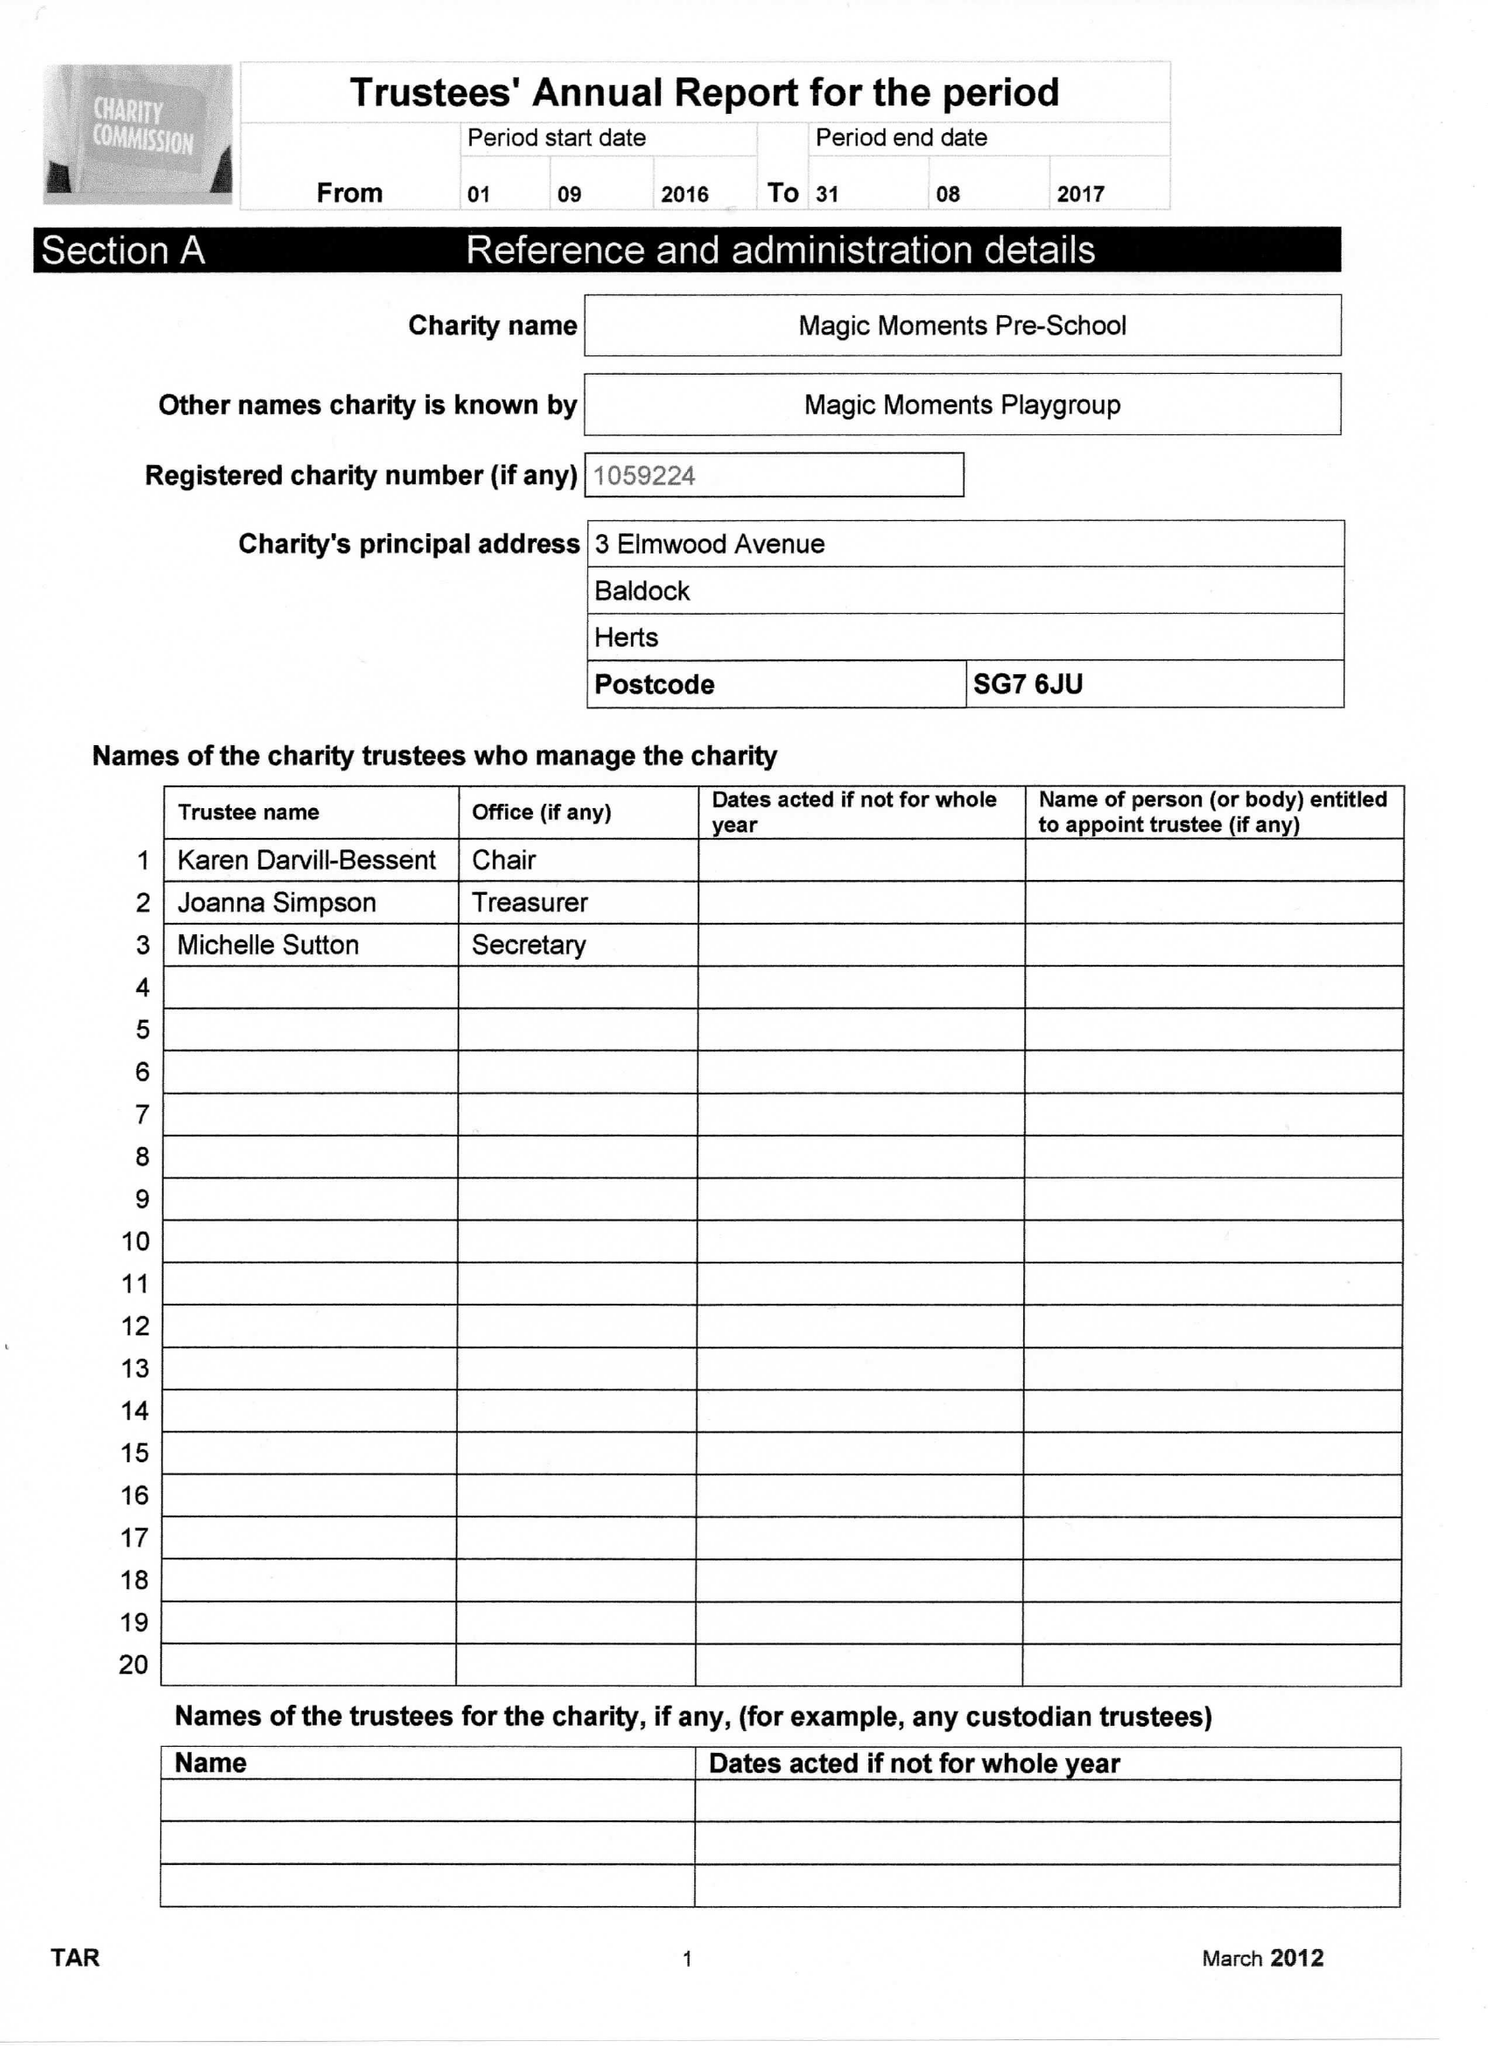What is the value for the charity_number?
Answer the question using a single word or phrase. 1059224 